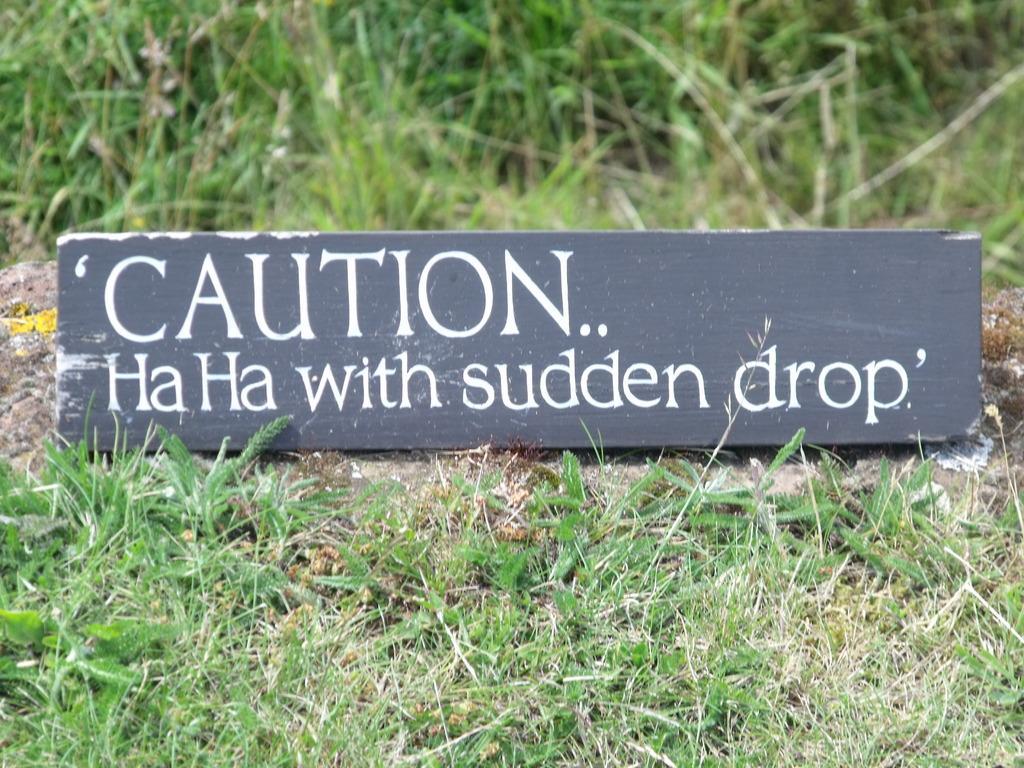In one or two sentences, can you explain what this image depicts? In this image we can see a grassy land. There is a board on with some text written on it. 